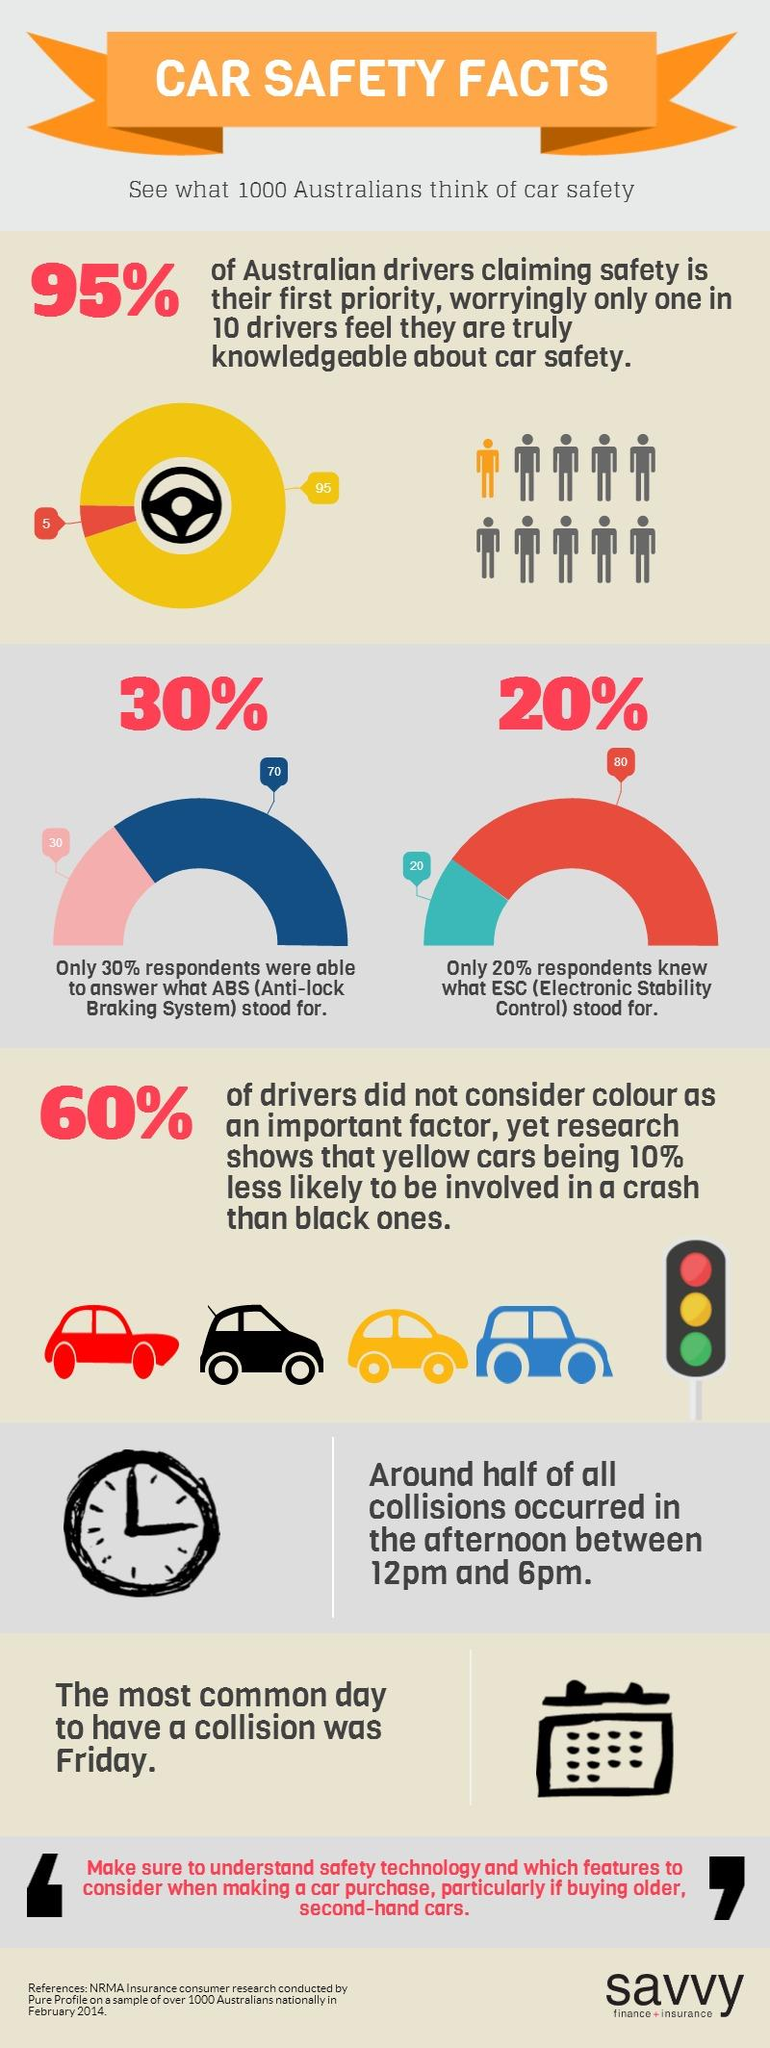Give some essential details in this illustration. According to a survey conducted in Australia, 80% of the population is unaware of the role of Electronic Stability Control in car safety. According to a research conducted in February 2014 among 1000 Australians, 40% of drivers considered color as an important factor in their decision-making process when purchasing a car. A significant percentage of Australians, approximately 70%, were unable to answer a question about the Anti-lock Braking System (ABS) in cars, highlighting a lack of knowledge and understanding about this important safety feature. 